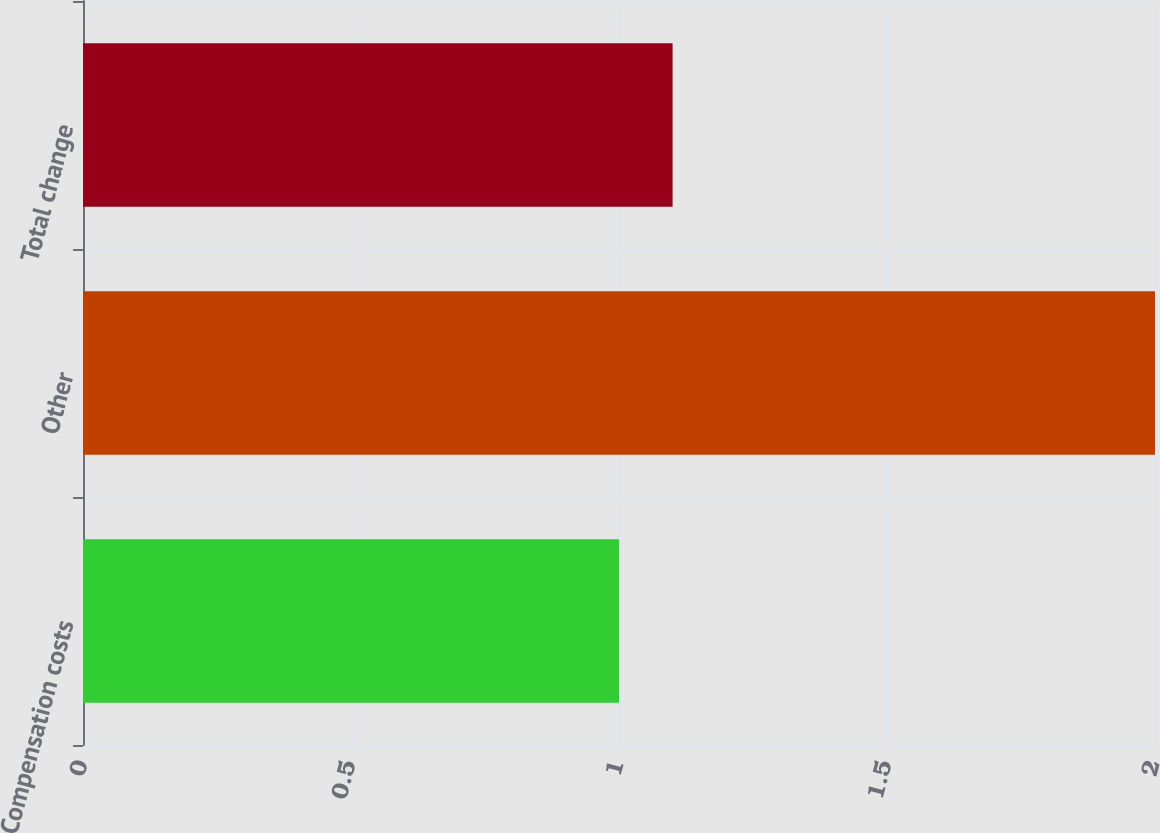Convert chart. <chart><loc_0><loc_0><loc_500><loc_500><bar_chart><fcel>Compensation costs<fcel>Other<fcel>Total change<nl><fcel>1<fcel>2<fcel>1.1<nl></chart> 